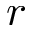<formula> <loc_0><loc_0><loc_500><loc_500>r</formula> 